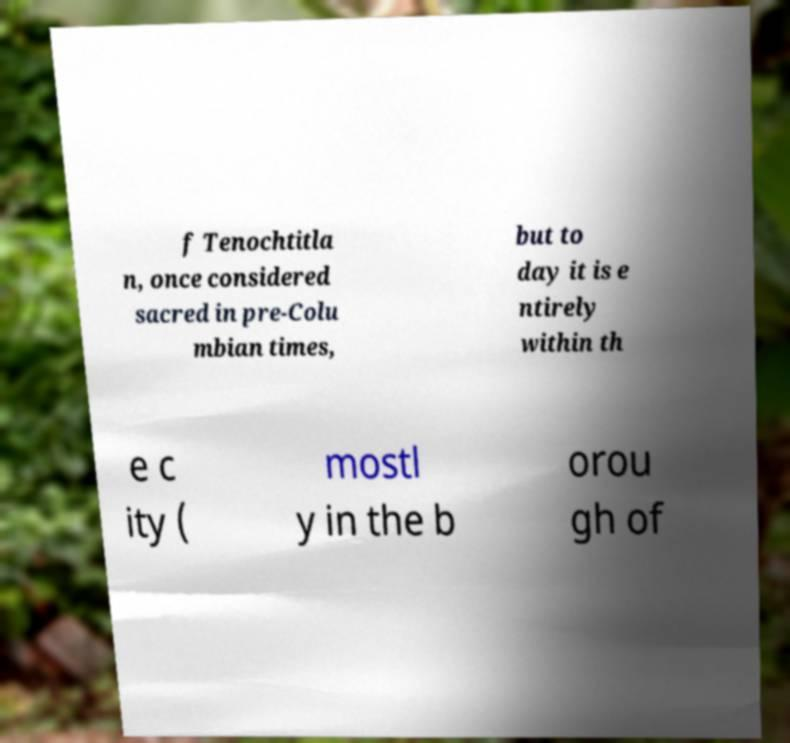Could you assist in decoding the text presented in this image and type it out clearly? f Tenochtitla n, once considered sacred in pre-Colu mbian times, but to day it is e ntirely within th e c ity ( mostl y in the b orou gh of 